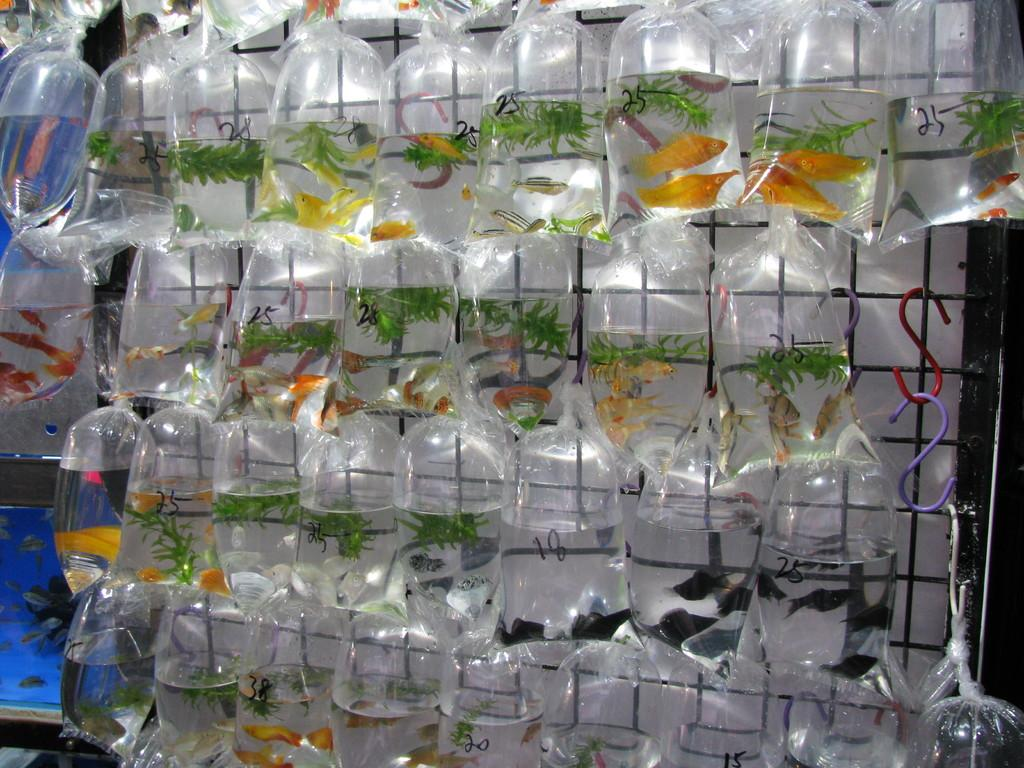What type of animals can be seen in the image? There are small fishes in the image. How are the small fishes being stored or transported? The small fishes are packed in covers. How are the covers with the small fishes attached to something? The small fishes are tied to some object. What type of cord is used to tie the family's dresses in the image? There is no mention of a family or dresses in the image; it features small fishes packed in covers and tied to some object. 